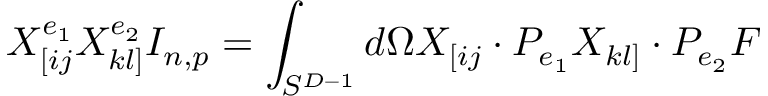<formula> <loc_0><loc_0><loc_500><loc_500>X _ { [ i j } ^ { e _ { 1 } } X _ { k l ] } ^ { e _ { 2 } } I _ { n , p } = \int _ { S ^ { D - 1 } } d \Omega X _ { [ i j } \cdot P _ { e _ { 1 } } X _ { k l ] } \cdot P _ { e _ { 2 } } F</formula> 